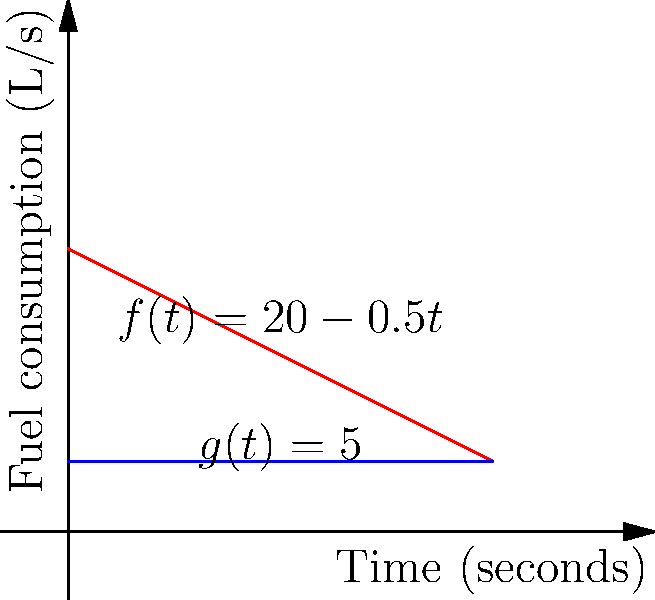As a precision driver, you're analyzing fuel consumption during a 30-second drag race. The fuel consumption rate (in liters per second) is given by the function $f(t) = 20 - 0.5t$, where $t$ is the time in seconds. If you were to maintain a constant fuel consumption rate of 5 L/s (represented by $g(t) = 5$), how many more liters of fuel would you consume compared to the variable consumption rate? Use integral calculus to solve this problem. Let's approach this step-by-step:

1) First, we need to calculate the total fuel consumed with the variable rate $f(t) = 20 - 0.5t$. This is the area under the curve of $f(t)$ from 0 to 30 seconds.

   $\int_0^{30} (20 - 0.5t) dt$

2) Solving this integral:
   $[20t - 0.25t^2]_0^{30}$
   $= (600 - 225) - (0 - 0) = 375$ liters

3) Now, let's calculate the fuel consumed at the constant rate $g(t) = 5$ for 30 seconds:

   $\int_0^{30} 5 dt = 5t|_0^{30} = 150$ liters

4) The difference in fuel consumption is:
   $150 - 375 = -225$ liters

The negative sign indicates that the constant rate consumes less fuel.

5) To find how many more liters are consumed with the variable rate, we take the absolute value:
   $|150 - 375| = 225$ liters
Answer: 225 liters 